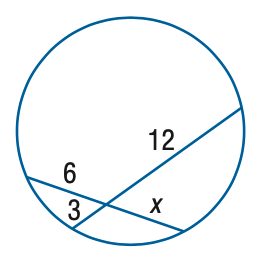Answer the mathemtical geometry problem and directly provide the correct option letter.
Question: Find x.
Choices: A: 3 B: 4 C: 5 D: 6 D 